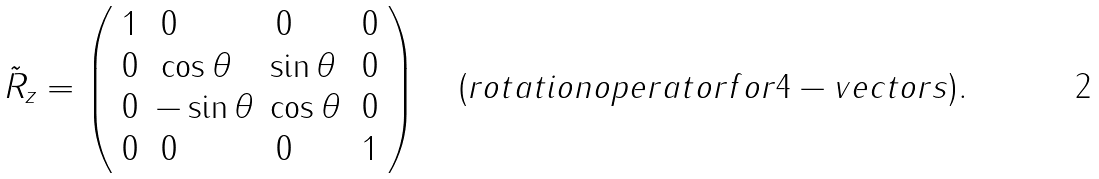Convert formula to latex. <formula><loc_0><loc_0><loc_500><loc_500>\tilde { R } _ { z } = \left ( \begin{array} { l l l l } { 1 } & { \, 0 } & { \, 0 } & { \, 0 } \\ { 0 } & { { \, \cos { \theta } } } & { { \sin { \theta } } } & { \, 0 } \\ { 0 } & { { - \sin { \theta } } } & { { \cos { \theta } } } & { \, 0 } \\ { 0 } & { \, 0 } & { \, 0 } & { \, 1 } \end{array} \right ) \quad ( r o t a t i o n o p e r a t o r f o r 4 - v e c t o r s ) .</formula> 